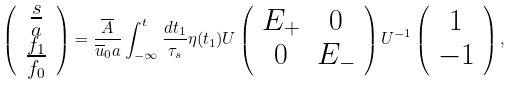<formula> <loc_0><loc_0><loc_500><loc_500>\left ( \begin{array} { c } \frac { s } { a } \\ \frac { f _ { 1 } } { f _ { 0 } } \end{array} \right ) = \frac { \overline { A } } { \overline { u } _ { 0 } a } \int _ { - \infty } ^ { t } \frac { d t _ { 1 } } { \tau _ { s } } \eta ( t _ { 1 } ) U \left ( \begin{array} { c c } E _ { + } & 0 \\ 0 & E _ { - } \end{array} \right ) U ^ { - 1 } \left ( \begin{array} { c } 1 \\ - 1 \end{array} \right ) ,</formula> 